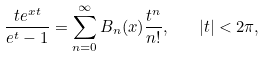Convert formula to latex. <formula><loc_0><loc_0><loc_500><loc_500>\frac { t e ^ { x t } } { e ^ { t } - 1 } = \sum _ { n = 0 } ^ { \infty } B _ { n } ( x ) \frac { t ^ { n } } { n ! } , \quad | t | < 2 \pi ,</formula> 